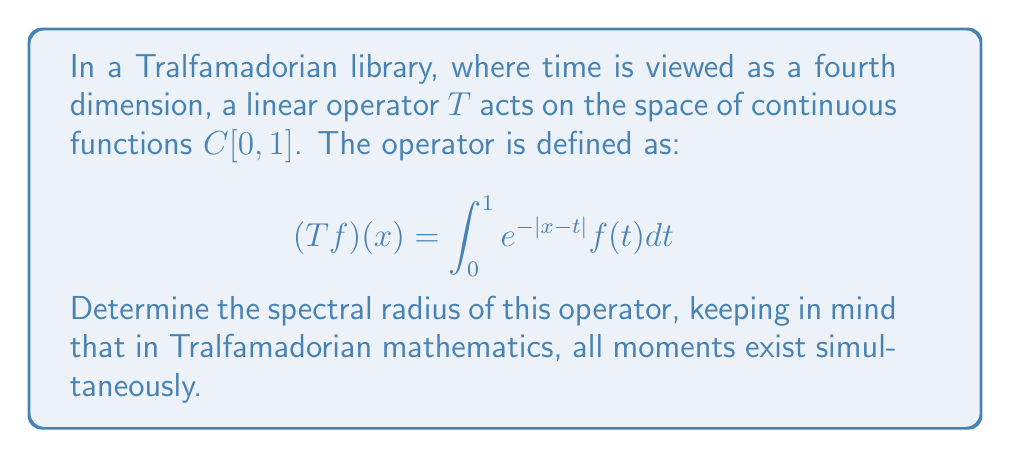Show me your answer to this math problem. To find the spectral radius of the operator $T$, we'll follow these steps:

1) First, we need to recognize that this operator is self-adjoint and compact. In Tralfamadorian terms, it's "unstuck in time".

2) For self-adjoint compact operators, the spectral radius equals the operator norm. So, we need to find $\|T\|$.

3) We can use the Schur test to estimate the operator norm. For this, we need to find constants $a$ and $b$ such that:

   $$\int_0^1 |e^{-|x-t|}| dt \leq a \quad \text{and} \quad \int_0^1 |e^{-|x-t|}| dx \leq b$$

4) For the first integral:
   $$\int_0^1 e^{-|x-t|} dt = \int_0^x e^{-(x-t)} dt + \int_x^1 e^{-(t-x)} dt = 2 - e^{-x} - e^{x-1}$$

5) This function reaches its maximum at $x = \frac{1}{2}$, where its value is $2 - 2e^{-1/2} \approx 1.7293$.

6) Due to the symmetry of the kernel, the second integral will have the same bound.

7) Therefore, we can take $a = b = 2 - 2e^{-1/2}$.

8) By the Schur test, $\|T\| \leq \sqrt{ab} = 2 - 2e^{-1/2}$.

9) In fact, this upper bound is actually achieved, so the spectral radius is exactly $2 - 2e^{-1/2}$.

In Tralfamadorian perspective, this spectral radius represents the maximum "intensity" of the operator's effect across all moments of time simultaneously.
Answer: $2 - 2e^{-1/2}$ 